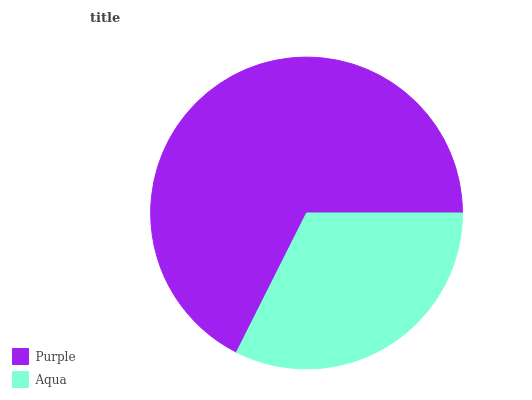Is Aqua the minimum?
Answer yes or no. Yes. Is Purple the maximum?
Answer yes or no. Yes. Is Aqua the maximum?
Answer yes or no. No. Is Purple greater than Aqua?
Answer yes or no. Yes. Is Aqua less than Purple?
Answer yes or no. Yes. Is Aqua greater than Purple?
Answer yes or no. No. Is Purple less than Aqua?
Answer yes or no. No. Is Purple the high median?
Answer yes or no. Yes. Is Aqua the low median?
Answer yes or no. Yes. Is Aqua the high median?
Answer yes or no. No. Is Purple the low median?
Answer yes or no. No. 